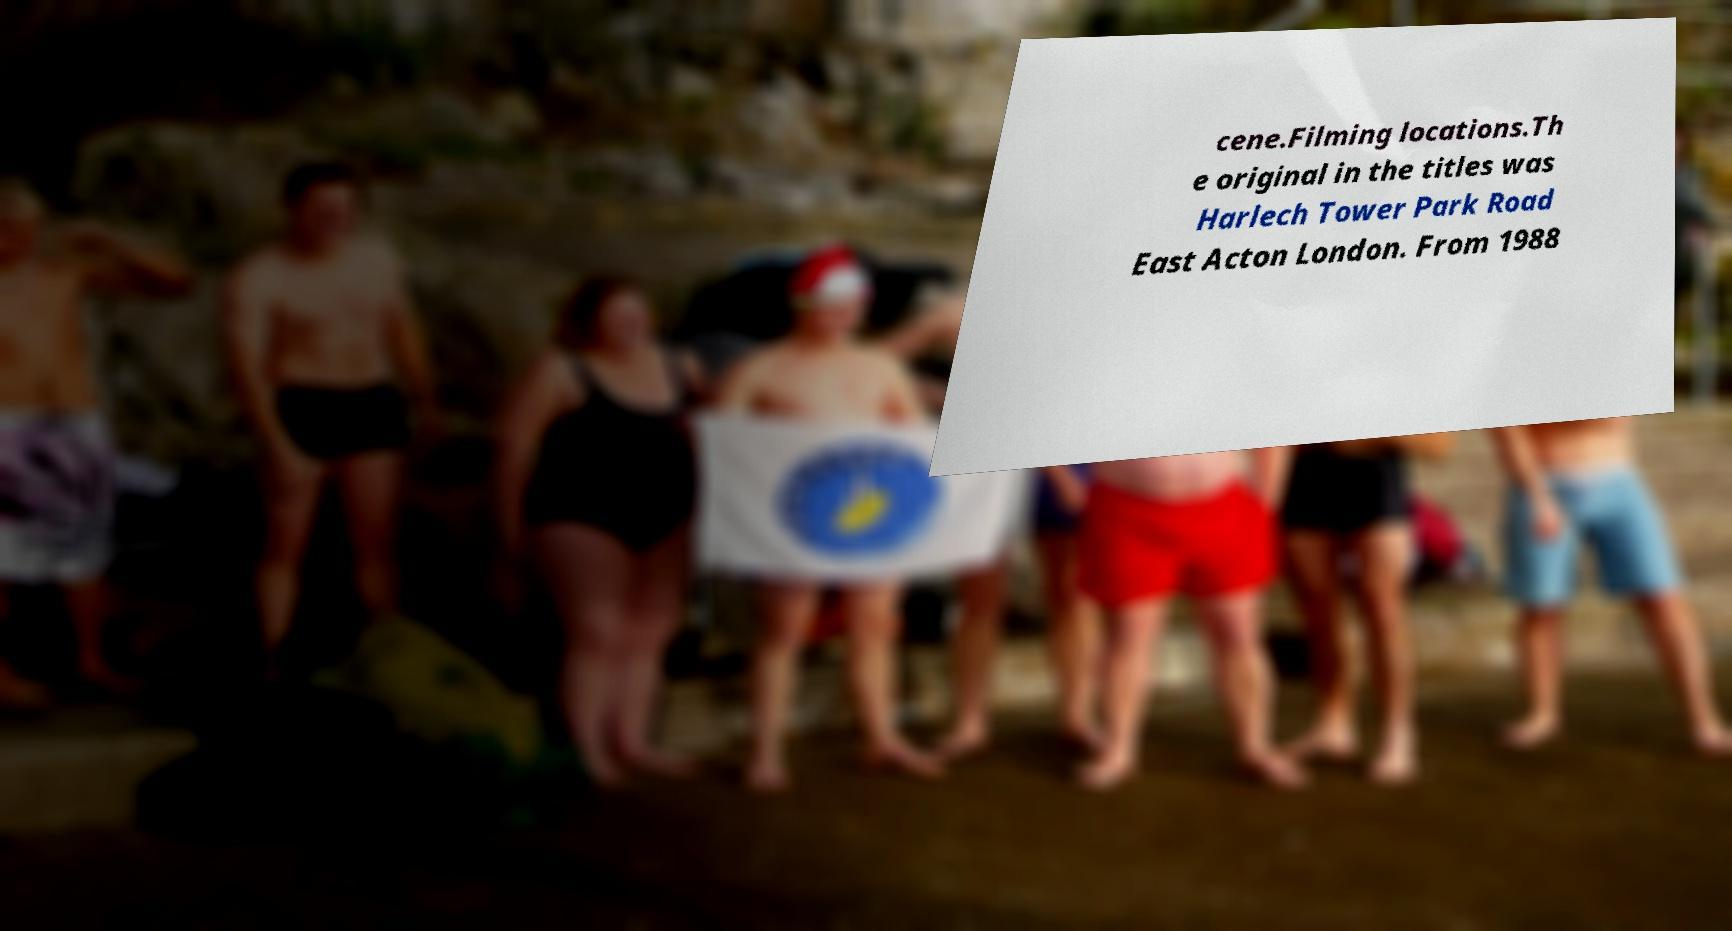Could you extract and type out the text from this image? cene.Filming locations.Th e original in the titles was Harlech Tower Park Road East Acton London. From 1988 